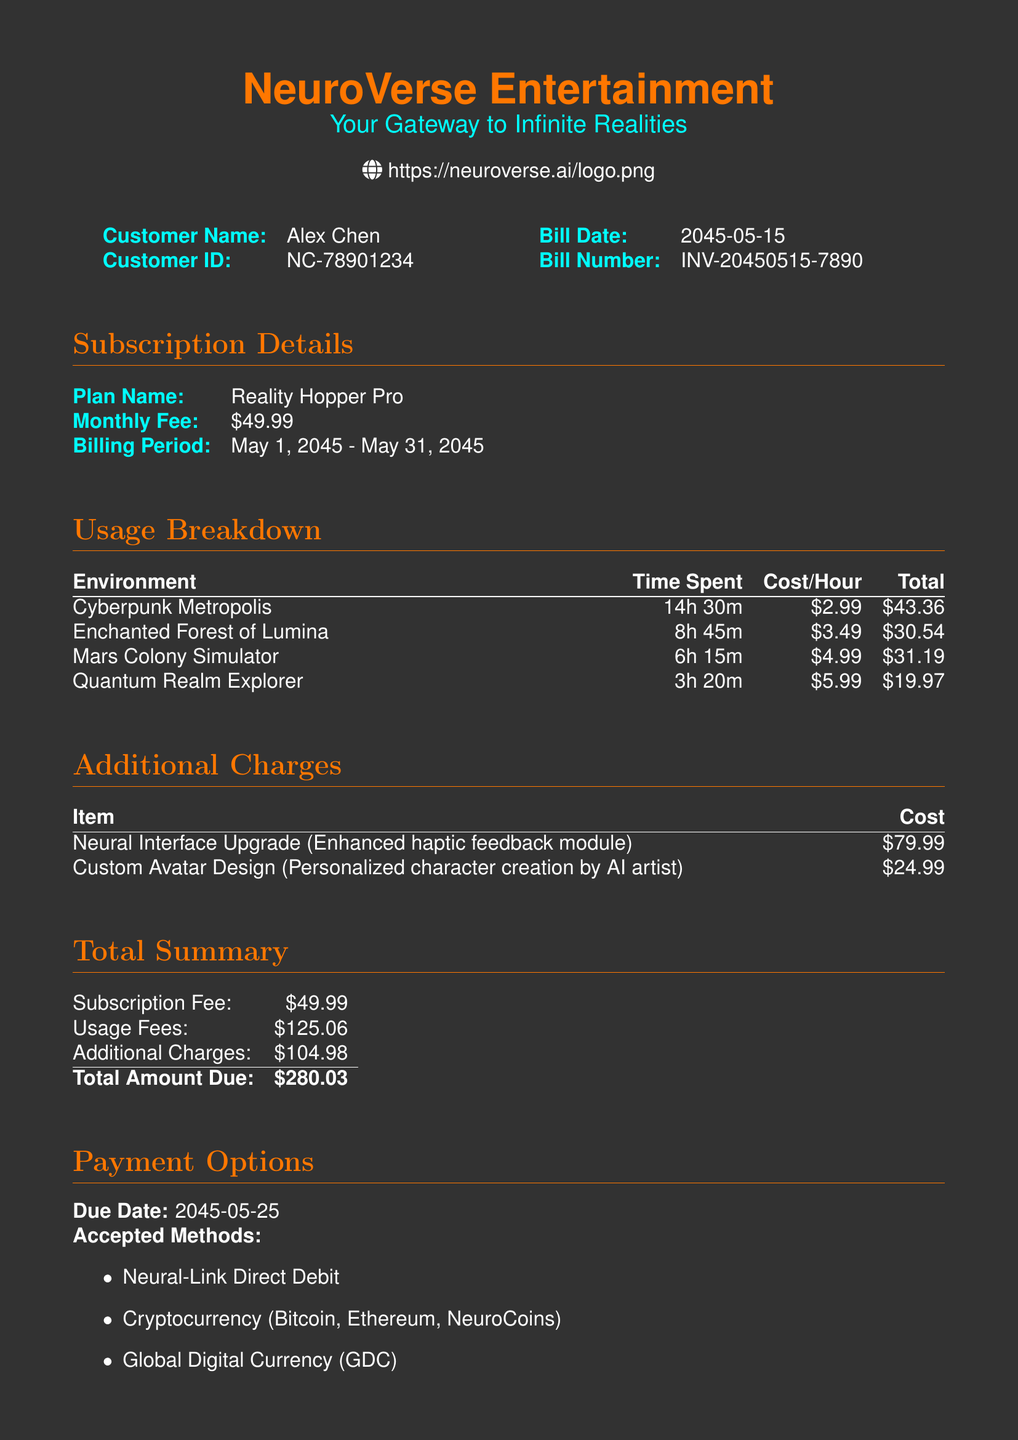What is the Customer Name? The customer name is provided in the billing information section.
Answer: Alex Chen What is the Bill Date? The bill date is indicated in the document and signifies when the bill was generated.
Answer: 2045-05-15 What is the Monthly Fee for the subscription plan? The monthly fee is stated under the subscription details section.
Answer: $49.99 How much time was spent in the Cyberpunk Metropolis? The time spent is detailed in the usage breakdown for the specific environment.
Answer: 14h 30m What is the total cost for the Enchanted Forest of Lumina? The total cost is derived from the usage breakdown and time spent in that environment.
Answer: $30.54 What is the total amount due? The total amount due is stated in the total summary section of the bill.
Answer: $280.03 How much does the Neural Interface Upgrade cost? The cost of the additional charge for the Neural Interface Upgrade is specified in the additional charges section.
Answer: $79.99 What accepted payment method is listed first? The accepted payment methods are listed in a specific order in the payment options section.
Answer: Neural-Link Direct Debit What is the due date for the payment? The due date is clearly indicated in the payment options section of the document.
Answer: 2045-05-25 